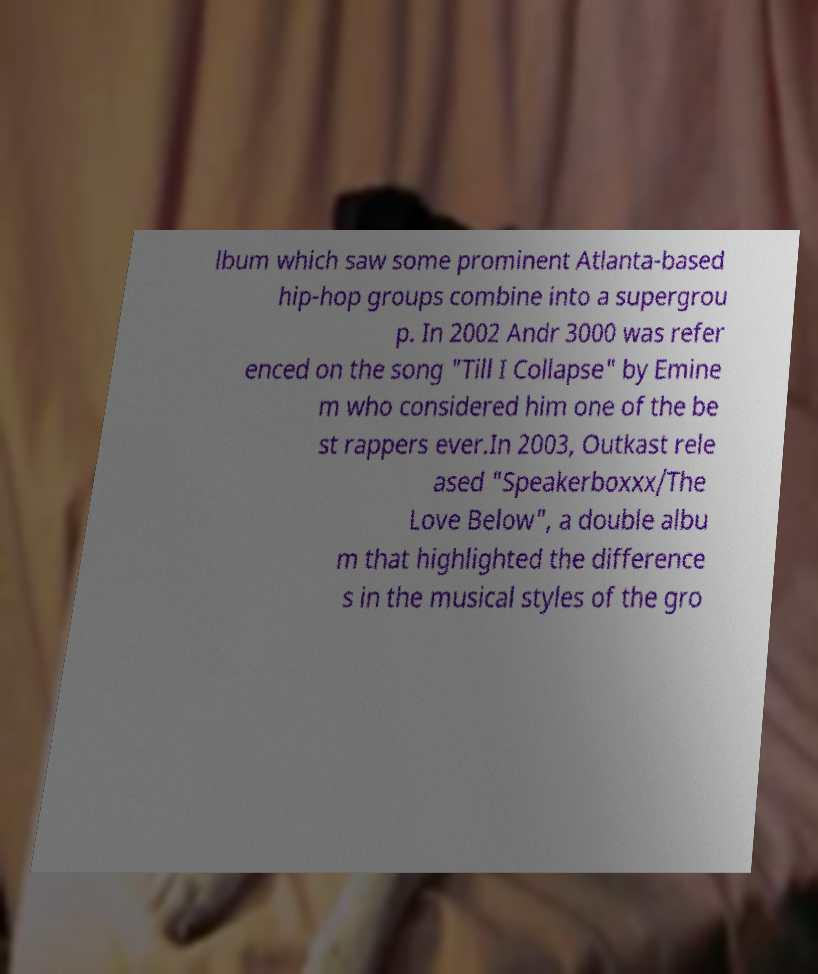Could you extract and type out the text from this image? lbum which saw some prominent Atlanta-based hip-hop groups combine into a supergrou p. In 2002 Andr 3000 was refer enced on the song "Till I Collapse" by Emine m who considered him one of the be st rappers ever.In 2003, Outkast rele ased "Speakerboxxx/The Love Below", a double albu m that highlighted the difference s in the musical styles of the gro 